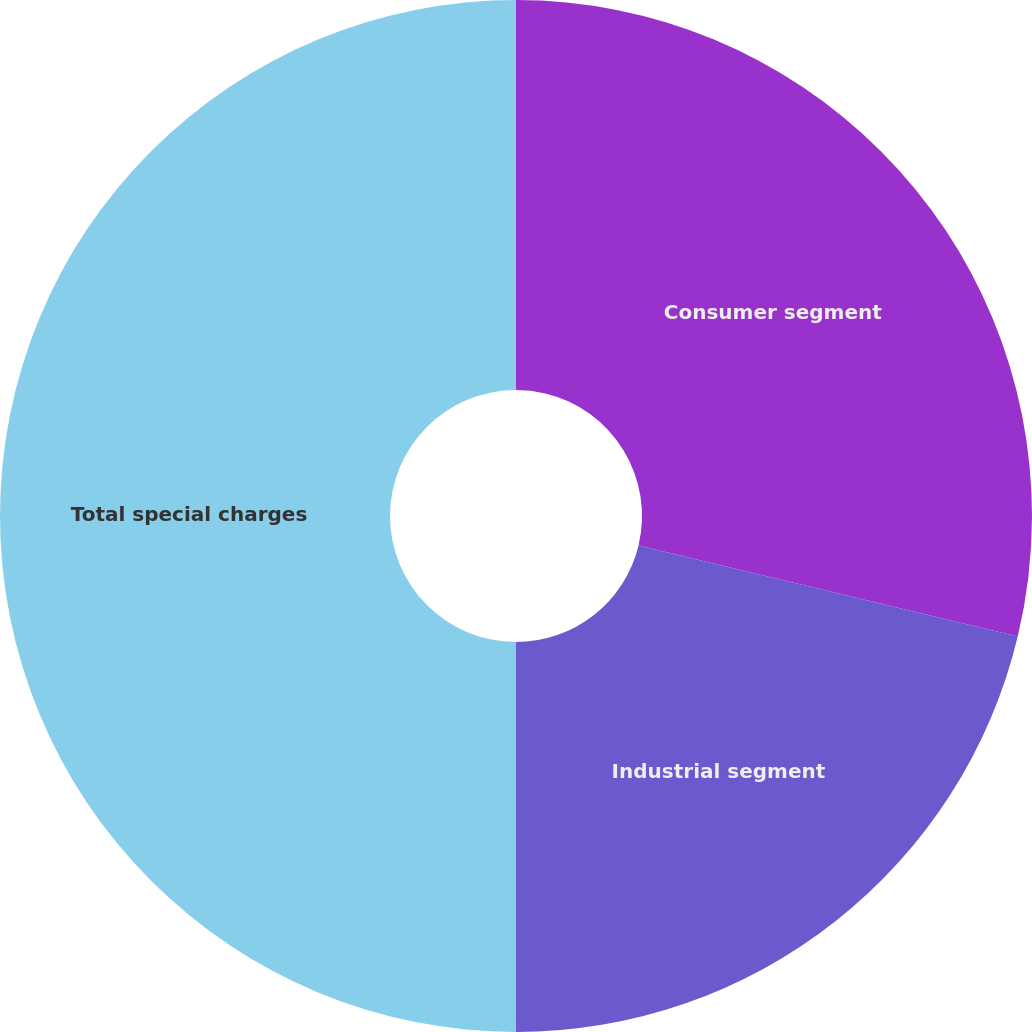Convert chart. <chart><loc_0><loc_0><loc_500><loc_500><pie_chart><fcel>Consumer segment<fcel>Industrial segment<fcel>Total special charges<nl><fcel>28.75%<fcel>21.25%<fcel>50.0%<nl></chart> 